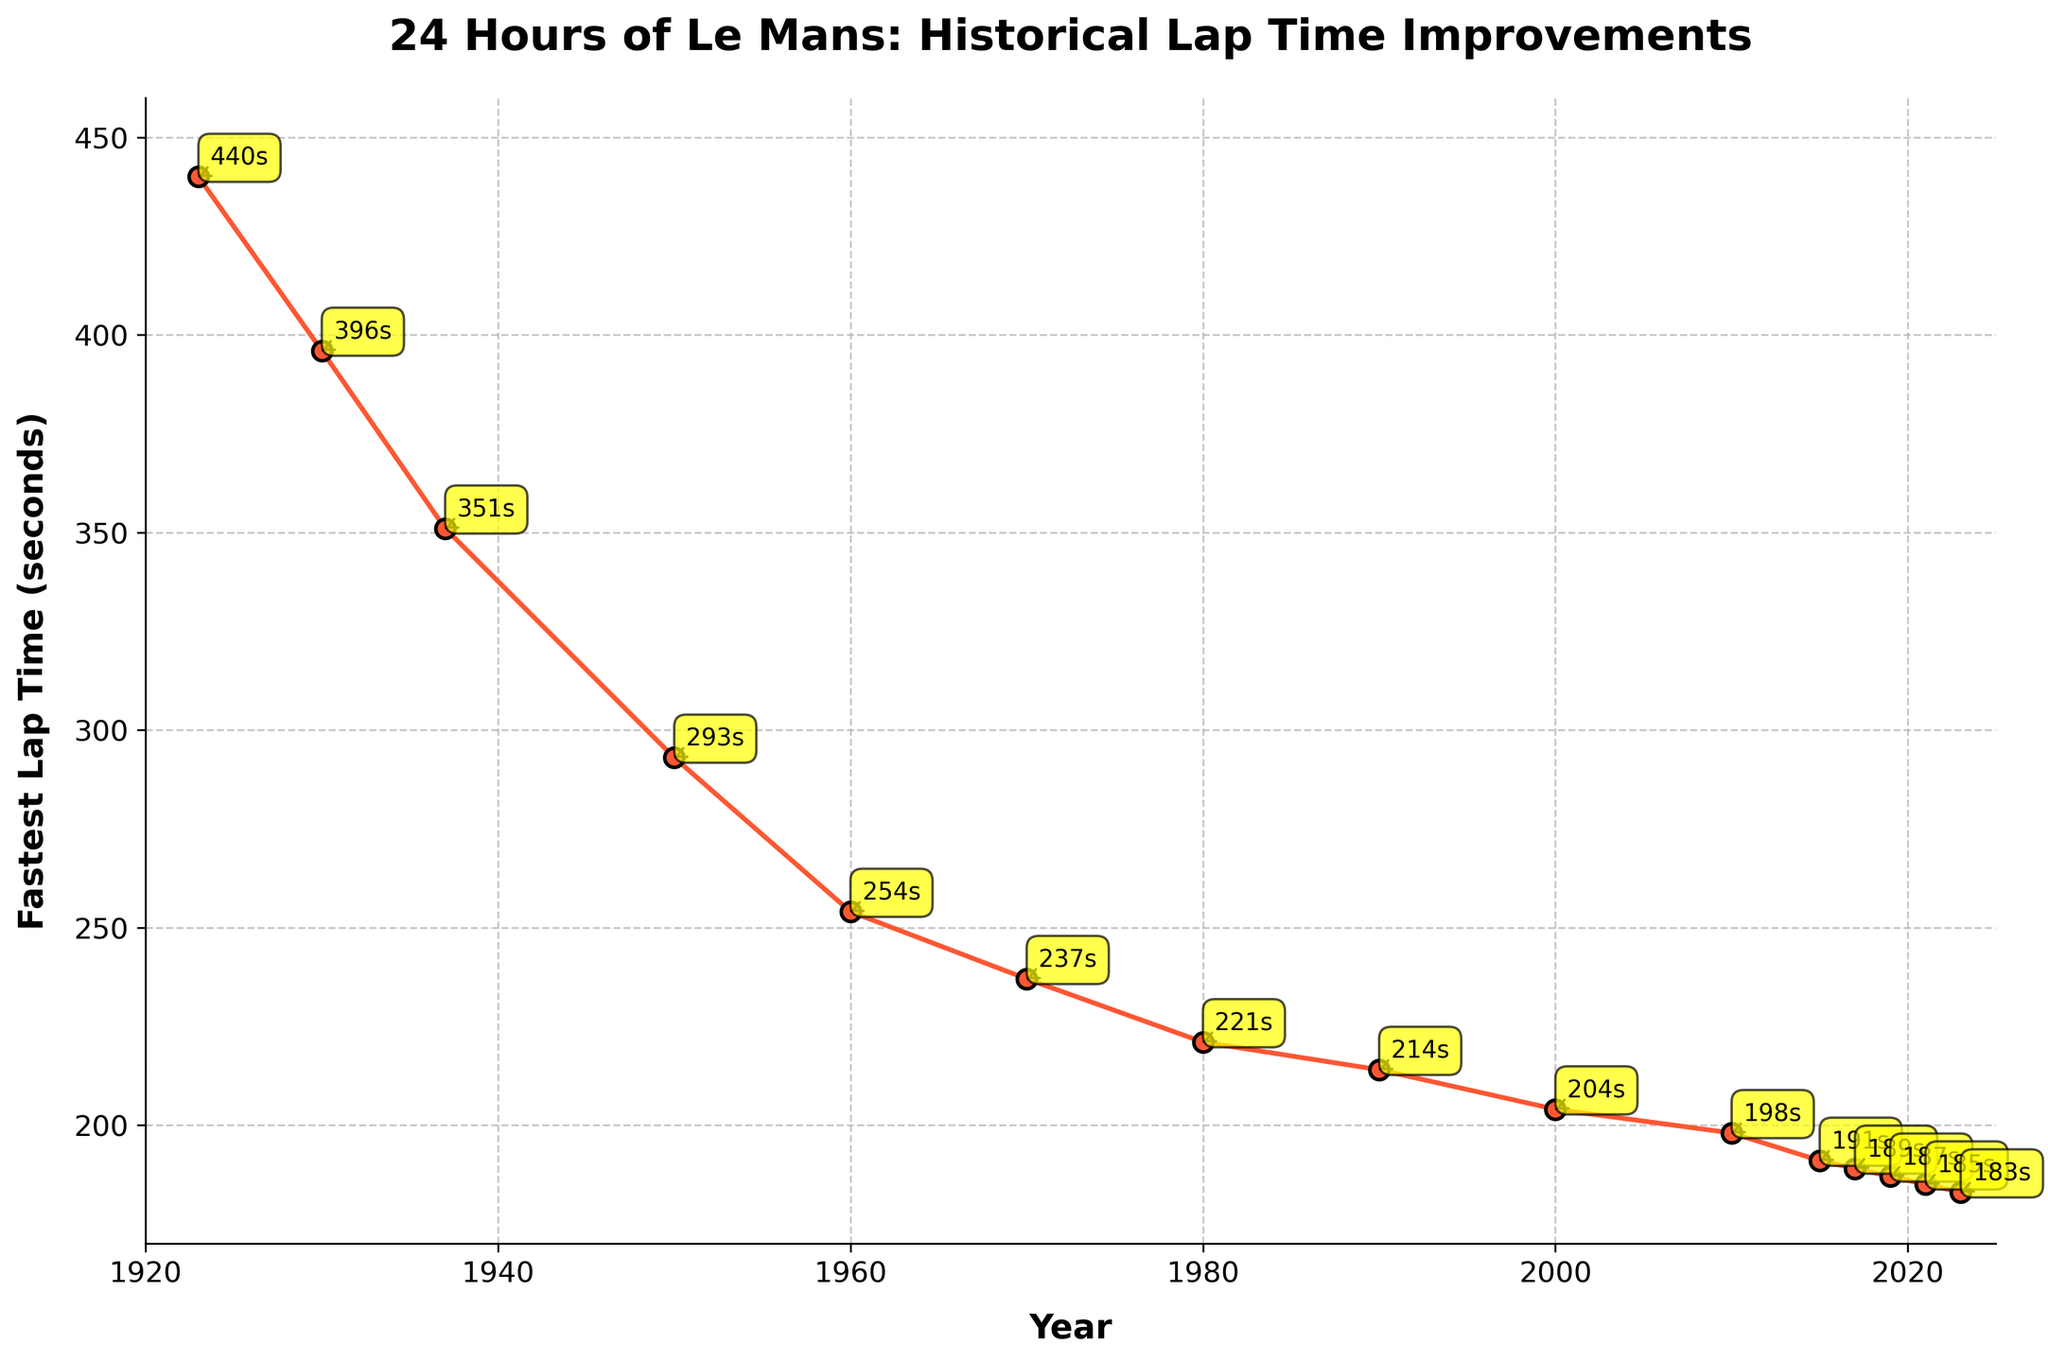Which year shows the fastest lap time? By inspecting the lowest point on the line chart, we can see that 2023 has the fastest lap time of 183 seconds
Answer: 2023 How much did the fastest lap time improve from 1923 to 2023? In 1923, the lap time was 440 seconds, and in 2023 it is 183 seconds. The improvement is calculated as 440 - 183
Answer: 257 seconds Between which consecutive years did the fastest lap time improve the most? By examining the sharpest downward slope between consecutive points, the biggest improvement occurred between 1950 (293 seconds) and 1960 (254 seconds). The difference is 293 - 254
Answer: 1950 to 1960 What is the average lap time from 2000 to 2023? The lap times from 2000 to 2023 are 204, 198, 191, 189, 187, 185, and 183 seconds. To find the average: (204 + 198 + 191 + 189 + 187 + 185 + 183) / 7
Answer: 191 seconds By how much did the lap time reduce from 1960 to 1970? The lap time in 1960 was 254 seconds, and in 1970 it is 237 seconds. The reduction is 254 - 237
Answer: 17 seconds Compare the lap time reduction between the periods 1930 to 1937 and 2015 to 2023. Which period had a greater reduction? From 1930 to 1937, the lap time reduced from 396 to 351 seconds, which is a reduction of 396 - 351 = 45 seconds. From 2015 to 2023, the lap time reduced from 191 to 183 seconds, which is a reduction of 191 - 183 = 8 seconds. Therefore, the period 1930 to 1937 had a greater reduction
Answer: 1930 to 1937 What is the trend observed in the lap times from 1923 to 2023? By looking at the overall direction of the line in the plot, we can see a consistent downward trend, indicating a reduction in lap times over the years
Answer: Decreasing trend What is the lap time difference between the years 1980 and 1990? In 1980, the lap time was 221 seconds, and in 1990 it was 214 seconds. The difference is 221 - 214
Answer: 7 seconds What was the lap time in 1950, and how does it compare to the lap time in 1960? From the plot, we can see that the lap time in 1950 was 293 seconds, and in 1960 it was 254 seconds. Comparing them, 293 is greater than 254
Answer: 1950 is greater decât 1960 